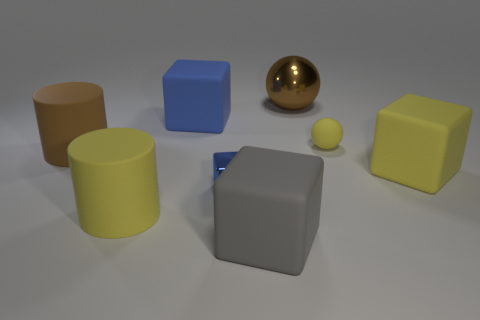Subtract all big blue cubes. How many cubes are left? 3 Subtract all blue blocks. How many blocks are left? 2 Add 1 blue metallic objects. How many objects exist? 9 Subtract all spheres. How many objects are left? 6 Subtract all gray spheres. How many blue cubes are left? 2 Subtract all yellow matte cylinders. Subtract all small blue metallic objects. How many objects are left? 6 Add 7 large brown cylinders. How many large brown cylinders are left? 8 Add 6 gray shiny things. How many gray shiny things exist? 6 Subtract 0 cyan cylinders. How many objects are left? 8 Subtract 1 cubes. How many cubes are left? 3 